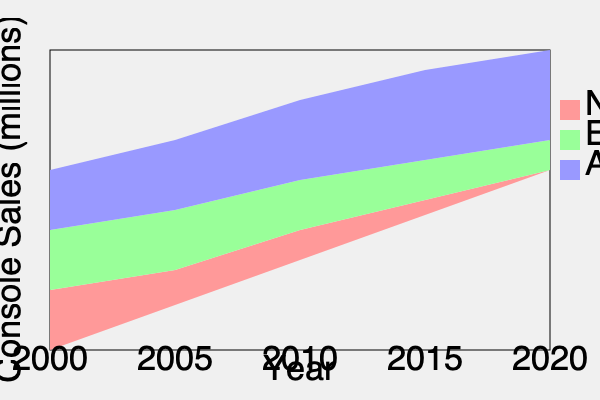Based on the stacked area chart showing video game console sales by region over time, which region has experienced the most significant growth in market share from 2000 to 2020? To determine which region has experienced the most significant growth in market share, we need to analyze the change in relative proportions of each region's area from 2000 to 2020:

1. North America (bottom layer, red):
   - 2000: Approximately 40% of total height
   - 2020: Approximately 40% of total height
   - Observation: Relatively stable market share

2. Europe (middle layer, green):
   - 2000: Approximately 20% of total height
   - 2020: Approximately 30% of total height
   - Observation: Moderate increase in market share

3. Asia (top layer, blue):
   - 2000: Approximately 40% of total height
   - 2020: Approximately 30% of total height
   - Observation: Decrease in market share

Comparing the changes:
- North America: No significant change
- Europe: Increase of about 10 percentage points
- Asia: Decrease of about 10 percentage points

Therefore, Europe has experienced the most significant growth in market share from 2000 to 2020.
Answer: Europe 